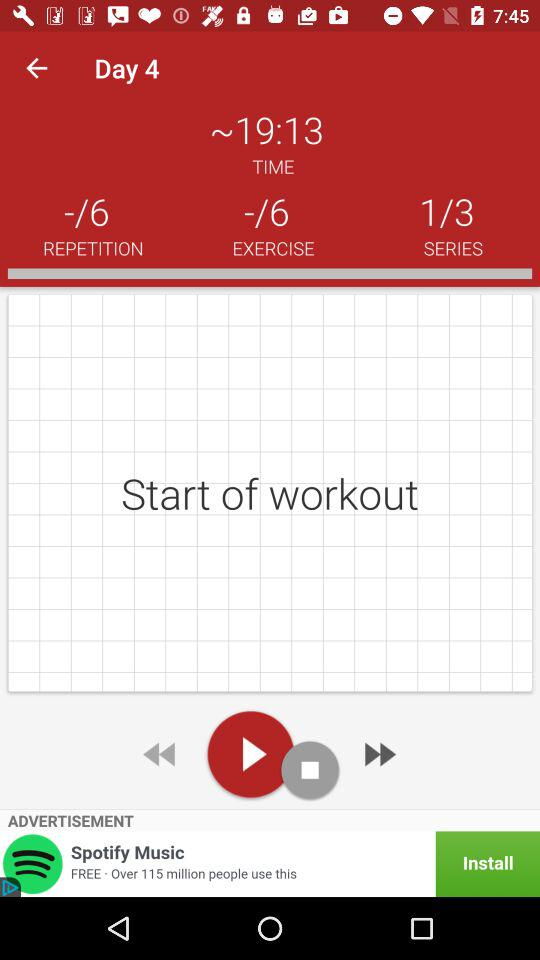Which series are we on out of three? You are in series 1. 